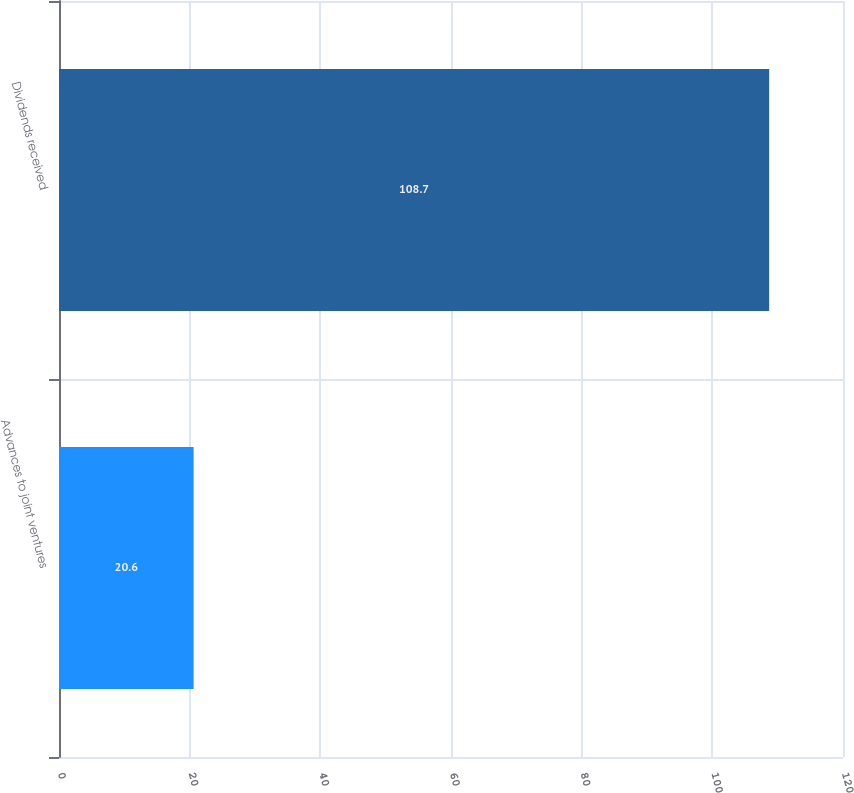<chart> <loc_0><loc_0><loc_500><loc_500><bar_chart><fcel>Advances to joint ventures<fcel>Dividends received<nl><fcel>20.6<fcel>108.7<nl></chart> 